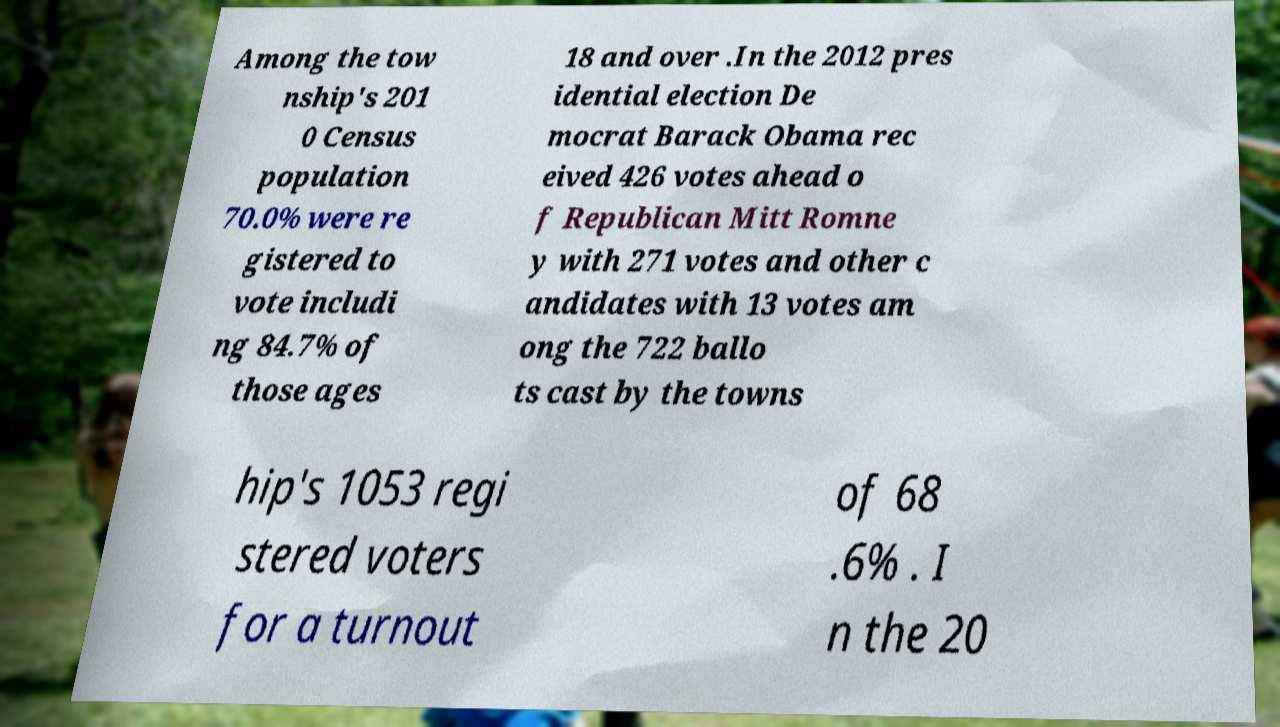I need the written content from this picture converted into text. Can you do that? Among the tow nship's 201 0 Census population 70.0% were re gistered to vote includi ng 84.7% of those ages 18 and over .In the 2012 pres idential election De mocrat Barack Obama rec eived 426 votes ahead o f Republican Mitt Romne y with 271 votes and other c andidates with 13 votes am ong the 722 ballo ts cast by the towns hip's 1053 regi stered voters for a turnout of 68 .6% . I n the 20 